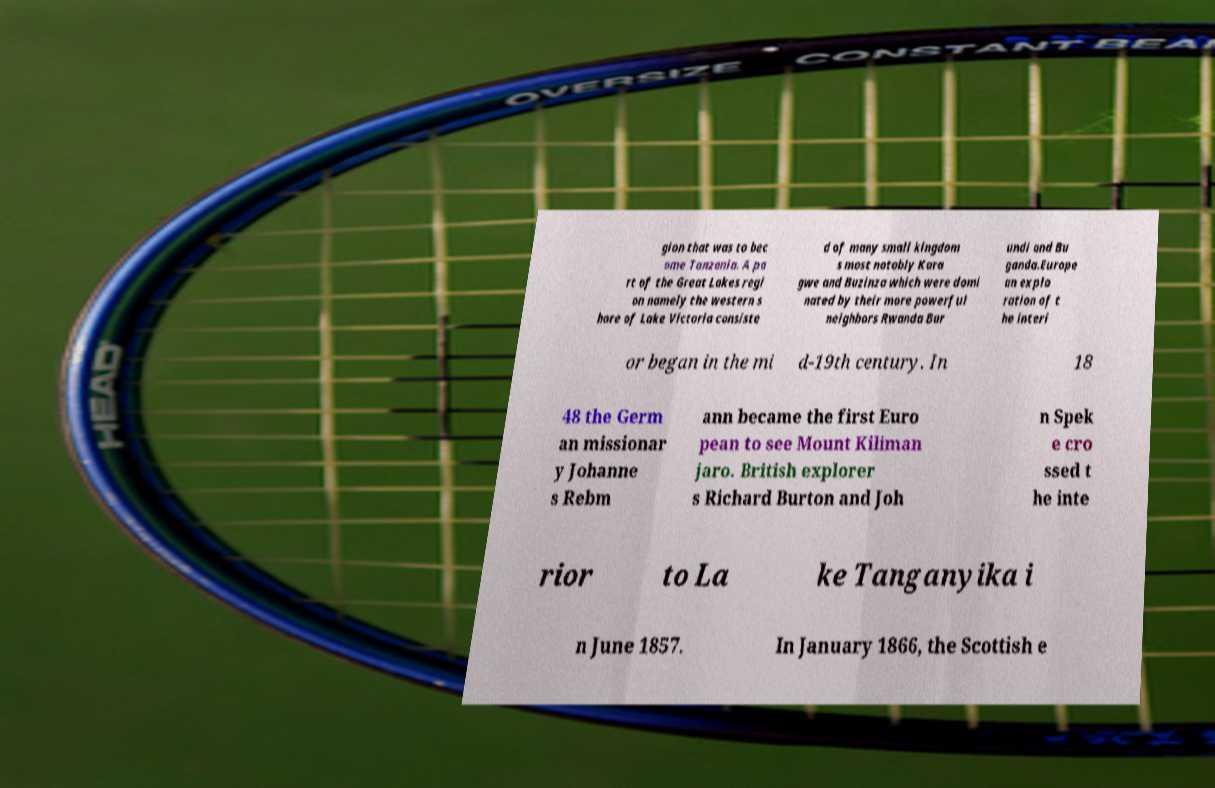I need the written content from this picture converted into text. Can you do that? gion that was to bec ome Tanzania. A pa rt of the Great Lakes regi on namely the western s hore of Lake Victoria consiste d of many small kingdom s most notably Kara gwe and Buzinza which were domi nated by their more powerful neighbors Rwanda Bur undi and Bu ganda.Europe an explo ration of t he interi or began in the mi d-19th century. In 18 48 the Germ an missionar y Johanne s Rebm ann became the first Euro pean to see Mount Kiliman jaro. British explorer s Richard Burton and Joh n Spek e cro ssed t he inte rior to La ke Tanganyika i n June 1857. In January 1866, the Scottish e 